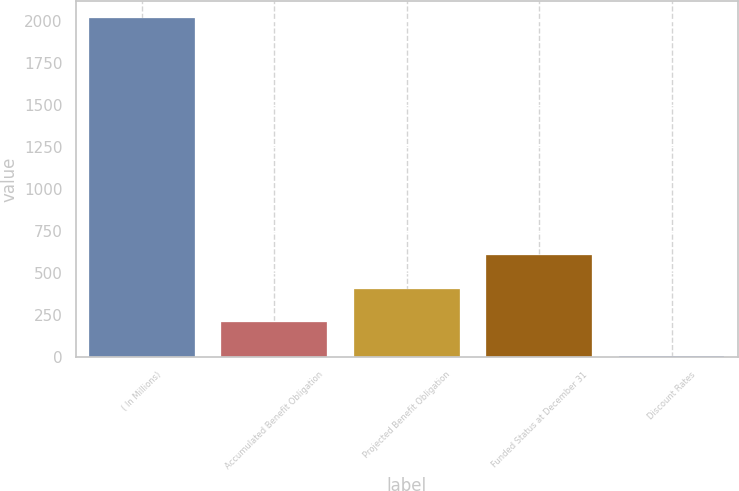Convert chart. <chart><loc_0><loc_0><loc_500><loc_500><bar_chart><fcel>( In Millions)<fcel>Accumulated Benefit Obligation<fcel>Projected Benefit Obligation<fcel>Funded Status at December 31<fcel>Discount Rates<nl><fcel>2016<fcel>205.61<fcel>406.76<fcel>607.91<fcel>4.46<nl></chart> 